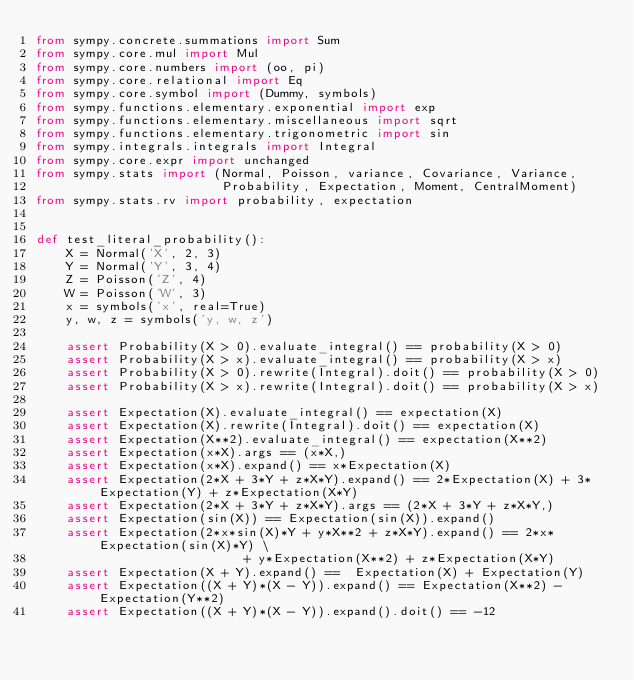Convert code to text. <code><loc_0><loc_0><loc_500><loc_500><_Python_>from sympy.concrete.summations import Sum
from sympy.core.mul import Mul
from sympy.core.numbers import (oo, pi)
from sympy.core.relational import Eq
from sympy.core.symbol import (Dummy, symbols)
from sympy.functions.elementary.exponential import exp
from sympy.functions.elementary.miscellaneous import sqrt
from sympy.functions.elementary.trigonometric import sin
from sympy.integrals.integrals import Integral
from sympy.core.expr import unchanged
from sympy.stats import (Normal, Poisson, variance, Covariance, Variance,
                         Probability, Expectation, Moment, CentralMoment)
from sympy.stats.rv import probability, expectation


def test_literal_probability():
    X = Normal('X', 2, 3)
    Y = Normal('Y', 3, 4)
    Z = Poisson('Z', 4)
    W = Poisson('W', 3)
    x = symbols('x', real=True)
    y, w, z = symbols('y, w, z')

    assert Probability(X > 0).evaluate_integral() == probability(X > 0)
    assert Probability(X > x).evaluate_integral() == probability(X > x)
    assert Probability(X > 0).rewrite(Integral).doit() == probability(X > 0)
    assert Probability(X > x).rewrite(Integral).doit() == probability(X > x)

    assert Expectation(X).evaluate_integral() == expectation(X)
    assert Expectation(X).rewrite(Integral).doit() == expectation(X)
    assert Expectation(X**2).evaluate_integral() == expectation(X**2)
    assert Expectation(x*X).args == (x*X,)
    assert Expectation(x*X).expand() == x*Expectation(X)
    assert Expectation(2*X + 3*Y + z*X*Y).expand() == 2*Expectation(X) + 3*Expectation(Y) + z*Expectation(X*Y)
    assert Expectation(2*X + 3*Y + z*X*Y).args == (2*X + 3*Y + z*X*Y,)
    assert Expectation(sin(X)) == Expectation(sin(X)).expand()
    assert Expectation(2*x*sin(X)*Y + y*X**2 + z*X*Y).expand() == 2*x*Expectation(sin(X)*Y) \
                            + y*Expectation(X**2) + z*Expectation(X*Y)
    assert Expectation(X + Y).expand() ==  Expectation(X) + Expectation(Y)
    assert Expectation((X + Y)*(X - Y)).expand() == Expectation(X**2) - Expectation(Y**2)
    assert Expectation((X + Y)*(X - Y)).expand().doit() == -12</code> 